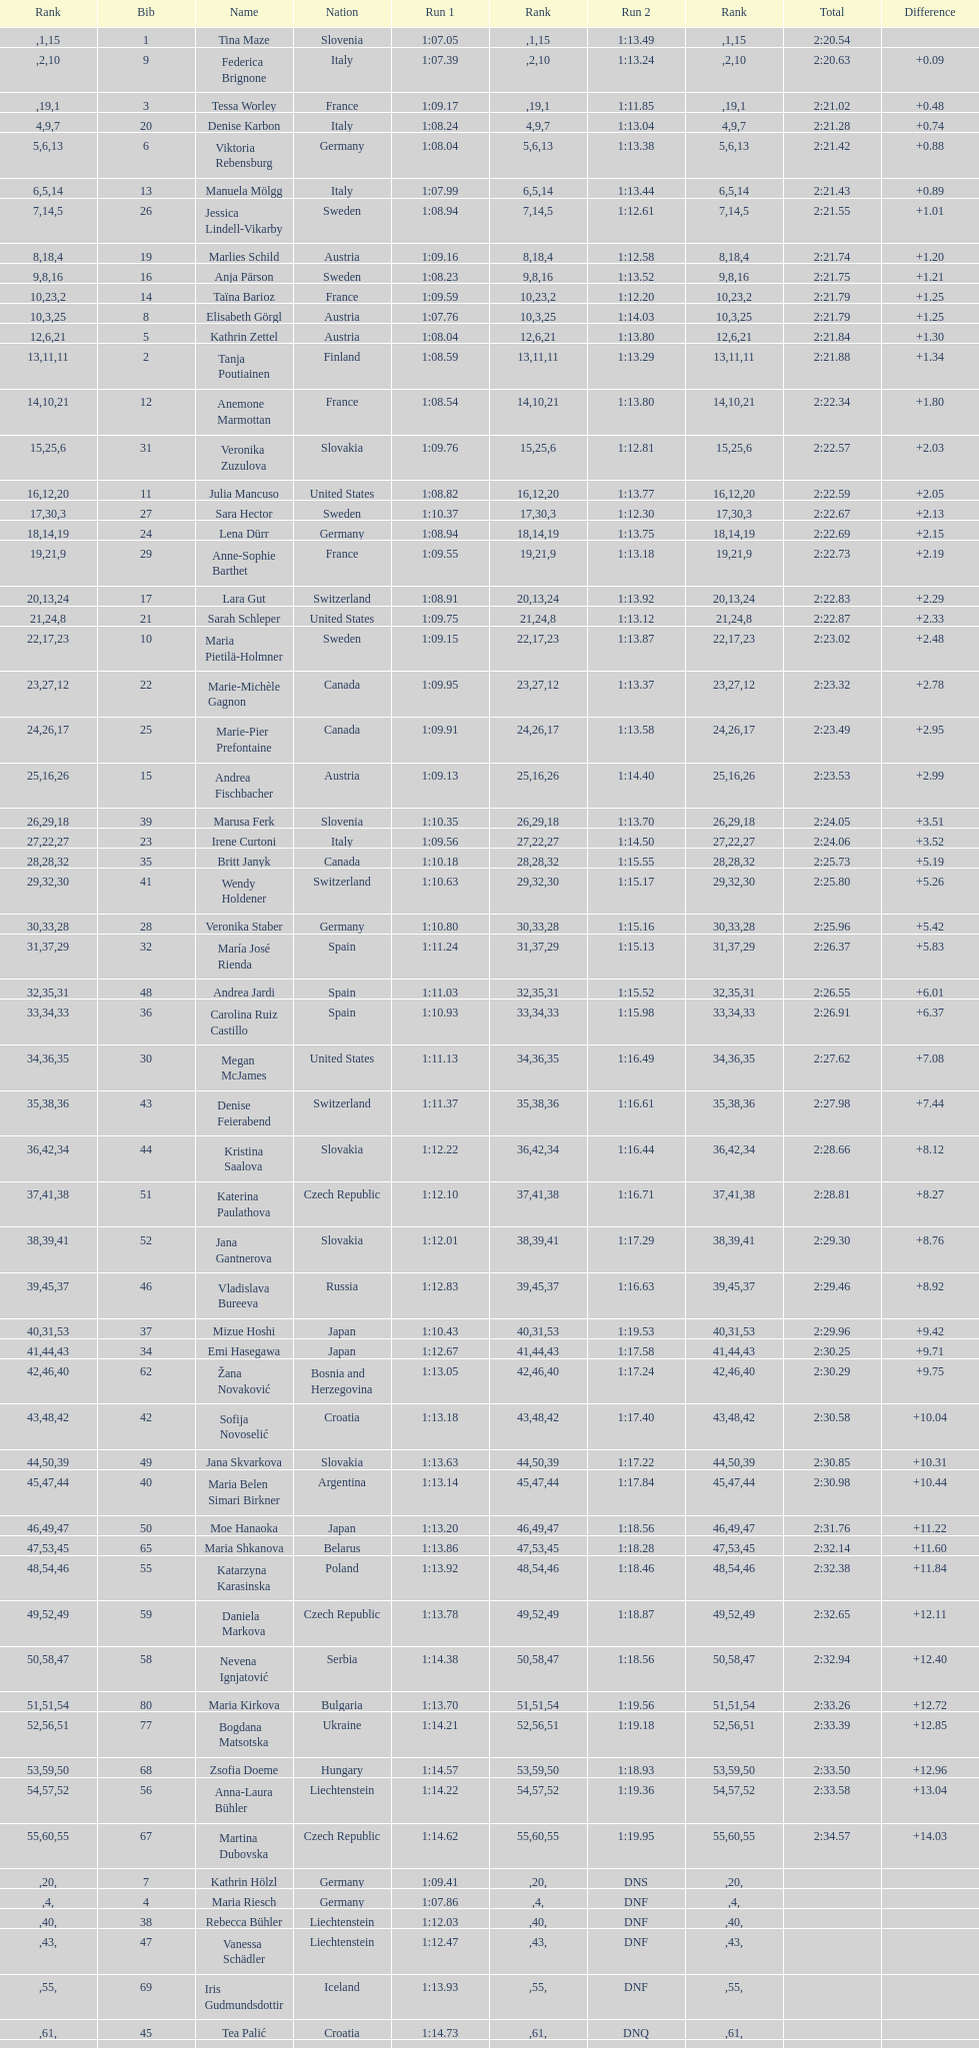Give me the full table as a dictionary. {'header': ['Rank', 'Bib', 'Name', 'Nation', 'Run 1', 'Rank', 'Run 2', 'Rank', 'Total', 'Difference'], 'rows': [['', '1', 'Tina Maze', 'Slovenia', '1:07.05', '1', '1:13.49', '15', '2:20.54', ''], ['', '9', 'Federica Brignone', 'Italy', '1:07.39', '2', '1:13.24', '10', '2:20.63', '+0.09'], ['', '3', 'Tessa Worley', 'France', '1:09.17', '19', '1:11.85', '1', '2:21.02', '+0.48'], ['4', '20', 'Denise Karbon', 'Italy', '1:08.24', '9', '1:13.04', '7', '2:21.28', '+0.74'], ['5', '6', 'Viktoria Rebensburg', 'Germany', '1:08.04', '6', '1:13.38', '13', '2:21.42', '+0.88'], ['6', '13', 'Manuela Mölgg', 'Italy', '1:07.99', '5', '1:13.44', '14', '2:21.43', '+0.89'], ['7', '26', 'Jessica Lindell-Vikarby', 'Sweden', '1:08.94', '14', '1:12.61', '5', '2:21.55', '+1.01'], ['8', '19', 'Marlies Schild', 'Austria', '1:09.16', '18', '1:12.58', '4', '2:21.74', '+1.20'], ['9', '16', 'Anja Pärson', 'Sweden', '1:08.23', '8', '1:13.52', '16', '2:21.75', '+1.21'], ['10', '14', 'Taïna Barioz', 'France', '1:09.59', '23', '1:12.20', '2', '2:21.79', '+1.25'], ['10', '8', 'Elisabeth Görgl', 'Austria', '1:07.76', '3', '1:14.03', '25', '2:21.79', '+1.25'], ['12', '5', 'Kathrin Zettel', 'Austria', '1:08.04', '6', '1:13.80', '21', '2:21.84', '+1.30'], ['13', '2', 'Tanja Poutiainen', 'Finland', '1:08.59', '11', '1:13.29', '11', '2:21.88', '+1.34'], ['14', '12', 'Anemone Marmottan', 'France', '1:08.54', '10', '1:13.80', '21', '2:22.34', '+1.80'], ['15', '31', 'Veronika Zuzulova', 'Slovakia', '1:09.76', '25', '1:12.81', '6', '2:22.57', '+2.03'], ['16', '11', 'Julia Mancuso', 'United States', '1:08.82', '12', '1:13.77', '20', '2:22.59', '+2.05'], ['17', '27', 'Sara Hector', 'Sweden', '1:10.37', '30', '1:12.30', '3', '2:22.67', '+2.13'], ['18', '24', 'Lena Dürr', 'Germany', '1:08.94', '14', '1:13.75', '19', '2:22.69', '+2.15'], ['19', '29', 'Anne-Sophie Barthet', 'France', '1:09.55', '21', '1:13.18', '9', '2:22.73', '+2.19'], ['20', '17', 'Lara Gut', 'Switzerland', '1:08.91', '13', '1:13.92', '24', '2:22.83', '+2.29'], ['21', '21', 'Sarah Schleper', 'United States', '1:09.75', '24', '1:13.12', '8', '2:22.87', '+2.33'], ['22', '10', 'Maria Pietilä-Holmner', 'Sweden', '1:09.15', '17', '1:13.87', '23', '2:23.02', '+2.48'], ['23', '22', 'Marie-Michèle Gagnon', 'Canada', '1:09.95', '27', '1:13.37', '12', '2:23.32', '+2.78'], ['24', '25', 'Marie-Pier Prefontaine', 'Canada', '1:09.91', '26', '1:13.58', '17', '2:23.49', '+2.95'], ['25', '15', 'Andrea Fischbacher', 'Austria', '1:09.13', '16', '1:14.40', '26', '2:23.53', '+2.99'], ['26', '39', 'Marusa Ferk', 'Slovenia', '1:10.35', '29', '1:13.70', '18', '2:24.05', '+3.51'], ['27', '23', 'Irene Curtoni', 'Italy', '1:09.56', '22', '1:14.50', '27', '2:24.06', '+3.52'], ['28', '35', 'Britt Janyk', 'Canada', '1:10.18', '28', '1:15.55', '32', '2:25.73', '+5.19'], ['29', '41', 'Wendy Holdener', 'Switzerland', '1:10.63', '32', '1:15.17', '30', '2:25.80', '+5.26'], ['30', '28', 'Veronika Staber', 'Germany', '1:10.80', '33', '1:15.16', '28', '2:25.96', '+5.42'], ['31', '32', 'María José Rienda', 'Spain', '1:11.24', '37', '1:15.13', '29', '2:26.37', '+5.83'], ['32', '48', 'Andrea Jardi', 'Spain', '1:11.03', '35', '1:15.52', '31', '2:26.55', '+6.01'], ['33', '36', 'Carolina Ruiz Castillo', 'Spain', '1:10.93', '34', '1:15.98', '33', '2:26.91', '+6.37'], ['34', '30', 'Megan McJames', 'United States', '1:11.13', '36', '1:16.49', '35', '2:27.62', '+7.08'], ['35', '43', 'Denise Feierabend', 'Switzerland', '1:11.37', '38', '1:16.61', '36', '2:27.98', '+7.44'], ['36', '44', 'Kristina Saalova', 'Slovakia', '1:12.22', '42', '1:16.44', '34', '2:28.66', '+8.12'], ['37', '51', 'Katerina Paulathova', 'Czech Republic', '1:12.10', '41', '1:16.71', '38', '2:28.81', '+8.27'], ['38', '52', 'Jana Gantnerova', 'Slovakia', '1:12.01', '39', '1:17.29', '41', '2:29.30', '+8.76'], ['39', '46', 'Vladislava Bureeva', 'Russia', '1:12.83', '45', '1:16.63', '37', '2:29.46', '+8.92'], ['40', '37', 'Mizue Hoshi', 'Japan', '1:10.43', '31', '1:19.53', '53', '2:29.96', '+9.42'], ['41', '34', 'Emi Hasegawa', 'Japan', '1:12.67', '44', '1:17.58', '43', '2:30.25', '+9.71'], ['42', '62', 'Žana Novaković', 'Bosnia and Herzegovina', '1:13.05', '46', '1:17.24', '40', '2:30.29', '+9.75'], ['43', '42', 'Sofija Novoselić', 'Croatia', '1:13.18', '48', '1:17.40', '42', '2:30.58', '+10.04'], ['44', '49', 'Jana Skvarkova', 'Slovakia', '1:13.63', '50', '1:17.22', '39', '2:30.85', '+10.31'], ['45', '40', 'Maria Belen Simari Birkner', 'Argentina', '1:13.14', '47', '1:17.84', '44', '2:30.98', '+10.44'], ['46', '50', 'Moe Hanaoka', 'Japan', '1:13.20', '49', '1:18.56', '47', '2:31.76', '+11.22'], ['47', '65', 'Maria Shkanova', 'Belarus', '1:13.86', '53', '1:18.28', '45', '2:32.14', '+11.60'], ['48', '55', 'Katarzyna Karasinska', 'Poland', '1:13.92', '54', '1:18.46', '46', '2:32.38', '+11.84'], ['49', '59', 'Daniela Markova', 'Czech Republic', '1:13.78', '52', '1:18.87', '49', '2:32.65', '+12.11'], ['50', '58', 'Nevena Ignjatović', 'Serbia', '1:14.38', '58', '1:18.56', '47', '2:32.94', '+12.40'], ['51', '80', 'Maria Kirkova', 'Bulgaria', '1:13.70', '51', '1:19.56', '54', '2:33.26', '+12.72'], ['52', '77', 'Bogdana Matsotska', 'Ukraine', '1:14.21', '56', '1:19.18', '51', '2:33.39', '+12.85'], ['53', '68', 'Zsofia Doeme', 'Hungary', '1:14.57', '59', '1:18.93', '50', '2:33.50', '+12.96'], ['54', '56', 'Anna-Laura Bühler', 'Liechtenstein', '1:14.22', '57', '1:19.36', '52', '2:33.58', '+13.04'], ['55', '67', 'Martina Dubovska', 'Czech Republic', '1:14.62', '60', '1:19.95', '55', '2:34.57', '+14.03'], ['', '7', 'Kathrin Hölzl', 'Germany', '1:09.41', '20', 'DNS', '', '', ''], ['', '4', 'Maria Riesch', 'Germany', '1:07.86', '4', 'DNF', '', '', ''], ['', '38', 'Rebecca Bühler', 'Liechtenstein', '1:12.03', '40', 'DNF', '', '', ''], ['', '47', 'Vanessa Schädler', 'Liechtenstein', '1:12.47', '43', 'DNF', '', '', ''], ['', '69', 'Iris Gudmundsdottir', 'Iceland', '1:13.93', '55', 'DNF', '', '', ''], ['', '45', 'Tea Palić', 'Croatia', '1:14.73', '61', 'DNQ', '', '', ''], ['', '74', 'Macarena Simari Birkner', 'Argentina', '1:15.18', '62', 'DNQ', '', '', ''], ['', '72', 'Lavinia Chrystal', 'Australia', '1:15.35', '63', 'DNQ', '', '', ''], ['', '81', 'Lelde Gasuna', 'Latvia', '1:15.37', '64', 'DNQ', '', '', ''], ['', '64', 'Aleksandra Klus', 'Poland', '1:15.41', '65', 'DNQ', '', '', ''], ['', '78', 'Nino Tsiklauri', 'Georgia', '1:15.54', '66', 'DNQ', '', '', ''], ['', '66', 'Sarah Jarvis', 'New Zealand', '1:15.94', '67', 'DNQ', '', '', ''], ['', '61', 'Anna Berecz', 'Hungary', '1:15.95', '68', 'DNQ', '', '', ''], ['', '83', 'Sandra-Elena Narea', 'Romania', '1:16.67', '69', 'DNQ', '', '', ''], ['', '85', 'Iulia Petruta Craciun', 'Romania', '1:16.80', '70', 'DNQ', '', '', ''], ['', '82', 'Isabel van Buynder', 'Belgium', '1:17.06', '71', 'DNQ', '', '', ''], ['', '97', 'Liene Fimbauere', 'Latvia', '1:17.83', '72', 'DNQ', '', '', ''], ['', '86', 'Kristina Krone', 'Puerto Rico', '1:17.93', '73', 'DNQ', '', '', ''], ['', '88', 'Nicole Valcareggi', 'Greece', '1:18.19', '74', 'DNQ', '', '', ''], ['', '100', 'Sophie Fjellvang-Sølling', 'Denmark', '1:18.37', '75', 'DNQ', '', '', ''], ['', '95', 'Ornella Oettl Reyes', 'Peru', '1:18.61', '76', 'DNQ', '', '', ''], ['', '73', 'Xia Lina', 'China', '1:19.12', '77', 'DNQ', '', '', ''], ['', '94', 'Kseniya Grigoreva', 'Uzbekistan', '1:19.16', '78', 'DNQ', '', '', ''], ['', '87', 'Tugba Dasdemir', 'Turkey', '1:21.50', '79', 'DNQ', '', '', ''], ['', '92', 'Malene Madsen', 'Denmark', '1:22.25', '80', 'DNQ', '', '', ''], ['', '84', 'Liu Yang', 'China', '1:22.80', '81', 'DNQ', '', '', ''], ['', '91', 'Yom Hirshfeld', 'Israel', '1:22.87', '82', 'DNQ', '', '', ''], ['', '75', 'Salome Bancora', 'Argentina', '1:23.08', '83', 'DNQ', '', '', ''], ['', '93', 'Ronnie Kiek-Gedalyahu', 'Israel', '1:23.38', '84', 'DNQ', '', '', ''], ['', '96', 'Chiara Marano', 'Brazil', '1:24.16', '85', 'DNQ', '', '', ''], ['', '113', 'Anne Libak Nielsen', 'Denmark', '1:25.08', '86', 'DNQ', '', '', ''], ['', '105', 'Donata Hellner', 'Hungary', '1:26.97', '87', 'DNQ', '', '', ''], ['', '102', 'Liu Yu', 'China', '1:27.03', '88', 'DNQ', '', '', ''], ['', '109', 'Lida Zvoznikova', 'Kyrgyzstan', '1:27.17', '89', 'DNQ', '', '', ''], ['', '103', 'Szelina Hellner', 'Hungary', '1:27.27', '90', 'DNQ', '', '', ''], ['', '114', 'Irina Volkova', 'Kyrgyzstan', '1:29.73', '91', 'DNQ', '', '', ''], ['', '106', 'Svetlana Baranova', 'Uzbekistan', '1:30.62', '92', 'DNQ', '', '', ''], ['', '108', 'Tatjana Baranova', 'Uzbekistan', '1:31.81', '93', 'DNQ', '', '', ''], ['', '110', 'Fatemeh Kiadarbandsari', 'Iran', '1:32.16', '94', 'DNQ', '', '', ''], ['', '107', 'Ziba Kalhor', 'Iran', '1:32.64', '95', 'DNQ', '', '', ''], ['', '104', 'Paraskevi Mavridou', 'Greece', '1:32.83', '96', 'DNQ', '', '', ''], ['', '99', 'Marjan Kalhor', 'Iran', '1:34.94', '97', 'DNQ', '', '', ''], ['', '112', 'Mitra Kalhor', 'Iran', '1:37.93', '98', 'DNQ', '', '', ''], ['', '115', 'Laura Bauer', 'South Africa', '1:42.19', '99', 'DNQ', '', '', ''], ['', '111', 'Sarah Ekmekejian', 'Lebanon', '1:42.22', '100', 'DNQ', '', '', ''], ['', '18', 'Fabienne Suter', 'Switzerland', 'DNS', '', '', '', '', ''], ['', '98', 'Maja Klepić', 'Bosnia and Herzegovina', 'DNS', '', '', '', '', ''], ['', '33', 'Agniezska Gasienica Daniel', 'Poland', 'DNF', '', '', '', '', ''], ['', '53', 'Karolina Chrapek', 'Poland', 'DNF', '', '', '', '', ''], ['', '54', 'Mireia Gutierrez', 'Andorra', 'DNF', '', '', '', '', ''], ['', '57', 'Brittany Phelan', 'Canada', 'DNF', '', '', '', '', ''], ['', '60', 'Tereza Kmochova', 'Czech Republic', 'DNF', '', '', '', '', ''], ['', '63', 'Michelle van Herwerden', 'Netherlands', 'DNF', '', '', '', '', ''], ['', '70', 'Maya Harrisson', 'Brazil', 'DNF', '', '', '', '', ''], ['', '71', 'Elizabeth Pilat', 'Australia', 'DNF', '', '', '', '', ''], ['', '76', 'Katrin Kristjansdottir', 'Iceland', 'DNF', '', '', '', '', ''], ['', '79', 'Julietta Quiroga', 'Argentina', 'DNF', '', '', '', '', ''], ['', '89', 'Evija Benhena', 'Latvia', 'DNF', '', '', '', '', ''], ['', '90', 'Qin Xiyue', 'China', 'DNF', '', '', '', '', ''], ['', '101', 'Sophia Ralli', 'Greece', 'DNF', '', '', '', '', ''], ['', '116', 'Siranush Maghakyan', 'Armenia', 'DNF', '', '', '', '', '']]} Who was the last competitor to actually finish both runs? Martina Dubovska. 